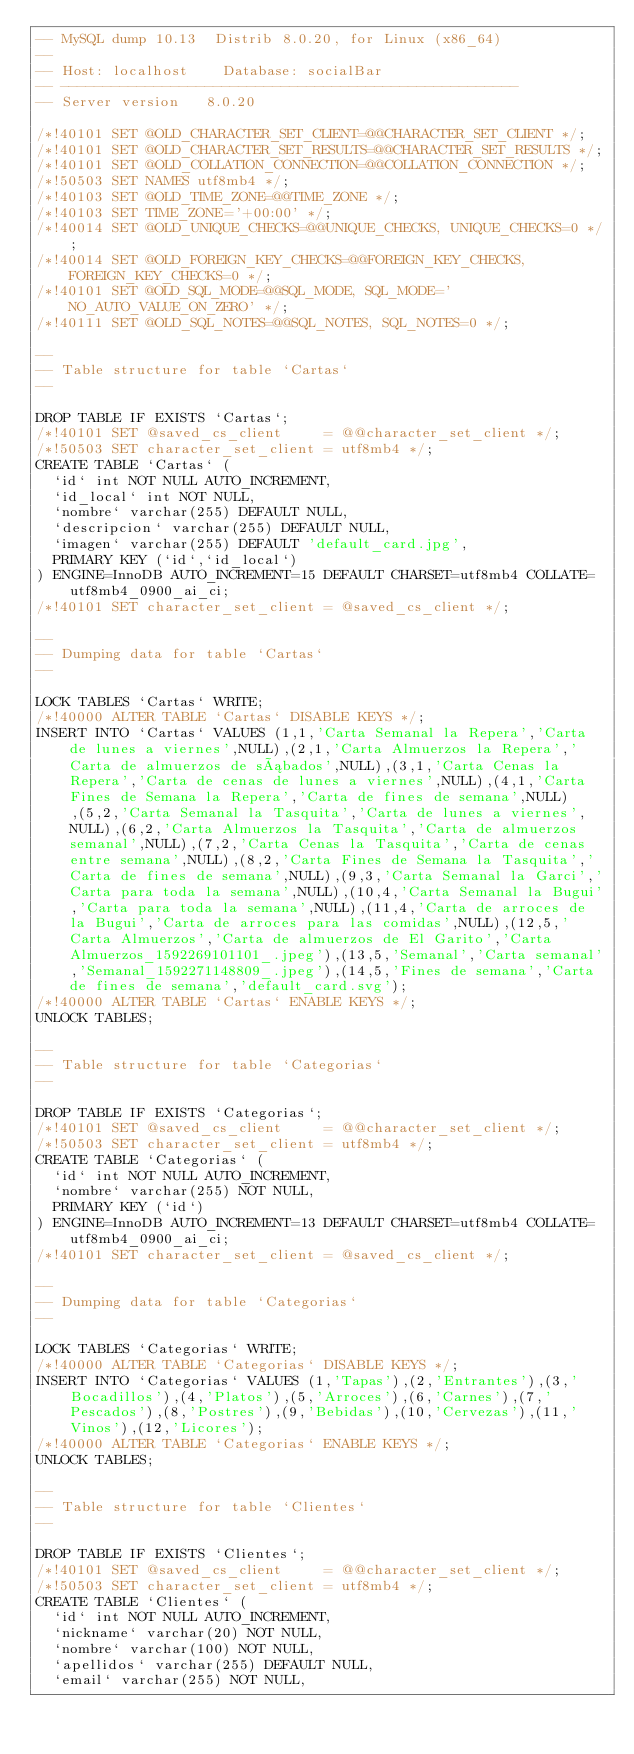Convert code to text. <code><loc_0><loc_0><loc_500><loc_500><_SQL_>-- MySQL dump 10.13  Distrib 8.0.20, for Linux (x86_64)
--
-- Host: localhost    Database: socialBar
-- ------------------------------------------------------
-- Server version	8.0.20

/*!40101 SET @OLD_CHARACTER_SET_CLIENT=@@CHARACTER_SET_CLIENT */;
/*!40101 SET @OLD_CHARACTER_SET_RESULTS=@@CHARACTER_SET_RESULTS */;
/*!40101 SET @OLD_COLLATION_CONNECTION=@@COLLATION_CONNECTION */;
/*!50503 SET NAMES utf8mb4 */;
/*!40103 SET @OLD_TIME_ZONE=@@TIME_ZONE */;
/*!40103 SET TIME_ZONE='+00:00' */;
/*!40014 SET @OLD_UNIQUE_CHECKS=@@UNIQUE_CHECKS, UNIQUE_CHECKS=0 */;
/*!40014 SET @OLD_FOREIGN_KEY_CHECKS=@@FOREIGN_KEY_CHECKS, FOREIGN_KEY_CHECKS=0 */;
/*!40101 SET @OLD_SQL_MODE=@@SQL_MODE, SQL_MODE='NO_AUTO_VALUE_ON_ZERO' */;
/*!40111 SET @OLD_SQL_NOTES=@@SQL_NOTES, SQL_NOTES=0 */;

--
-- Table structure for table `Cartas`
--

DROP TABLE IF EXISTS `Cartas`;
/*!40101 SET @saved_cs_client     = @@character_set_client */;
/*!50503 SET character_set_client = utf8mb4 */;
CREATE TABLE `Cartas` (
  `id` int NOT NULL AUTO_INCREMENT,
  `id_local` int NOT NULL,
  `nombre` varchar(255) DEFAULT NULL,
  `descripcion` varchar(255) DEFAULT NULL,
  `imagen` varchar(255) DEFAULT 'default_card.jpg',
  PRIMARY KEY (`id`,`id_local`)
) ENGINE=InnoDB AUTO_INCREMENT=15 DEFAULT CHARSET=utf8mb4 COLLATE=utf8mb4_0900_ai_ci;
/*!40101 SET character_set_client = @saved_cs_client */;

--
-- Dumping data for table `Cartas`
--

LOCK TABLES `Cartas` WRITE;
/*!40000 ALTER TABLE `Cartas` DISABLE KEYS */;
INSERT INTO `Cartas` VALUES (1,1,'Carta Semanal la Repera','Carta de lunes a viernes',NULL),(2,1,'Carta Almuerzos la Repera','Carta de almuerzos de sábados',NULL),(3,1,'Carta Cenas la Repera','Carta de cenas de lunes a viernes',NULL),(4,1,'Carta Fines de Semana la Repera','Carta de fines de semana',NULL),(5,2,'Carta Semanal la Tasquita','Carta de lunes a viernes',NULL),(6,2,'Carta Almuerzos la Tasquita','Carta de almuerzos semanal',NULL),(7,2,'Carta Cenas la Tasquita','Carta de cenas entre semana',NULL),(8,2,'Carta Fines de Semana la Tasquita','Carta de fines de semana',NULL),(9,3,'Carta Semanal la Garci','Carta para toda la semana',NULL),(10,4,'Carta Semanal la Bugui','Carta para toda la semana',NULL),(11,4,'Carta de arroces de la Bugui','Carta de arroces para las comidas',NULL),(12,5,'Carta Almuerzos','Carta de almuerzos de El Garito','Carta Almuerzos_1592269101101_.jpeg'),(13,5,'Semanal','Carta semanal','Semanal_1592271148809_.jpeg'),(14,5,'Fines de semana','Carta de fines de semana','default_card.svg');
/*!40000 ALTER TABLE `Cartas` ENABLE KEYS */;
UNLOCK TABLES;

--
-- Table structure for table `Categorias`
--

DROP TABLE IF EXISTS `Categorias`;
/*!40101 SET @saved_cs_client     = @@character_set_client */;
/*!50503 SET character_set_client = utf8mb4 */;
CREATE TABLE `Categorias` (
  `id` int NOT NULL AUTO_INCREMENT,
  `nombre` varchar(255) NOT NULL,
  PRIMARY KEY (`id`)
) ENGINE=InnoDB AUTO_INCREMENT=13 DEFAULT CHARSET=utf8mb4 COLLATE=utf8mb4_0900_ai_ci;
/*!40101 SET character_set_client = @saved_cs_client */;

--
-- Dumping data for table `Categorias`
--

LOCK TABLES `Categorias` WRITE;
/*!40000 ALTER TABLE `Categorias` DISABLE KEYS */;
INSERT INTO `Categorias` VALUES (1,'Tapas'),(2,'Entrantes'),(3,'Bocadillos'),(4,'Platos'),(5,'Arroces'),(6,'Carnes'),(7,'Pescados'),(8,'Postres'),(9,'Bebidas'),(10,'Cervezas'),(11,'Vinos'),(12,'Licores');
/*!40000 ALTER TABLE `Categorias` ENABLE KEYS */;
UNLOCK TABLES;

--
-- Table structure for table `Clientes`
--

DROP TABLE IF EXISTS `Clientes`;
/*!40101 SET @saved_cs_client     = @@character_set_client */;
/*!50503 SET character_set_client = utf8mb4 */;
CREATE TABLE `Clientes` (
  `id` int NOT NULL AUTO_INCREMENT,
  `nickname` varchar(20) NOT NULL,
  `nombre` varchar(100) NOT NULL,
  `apellidos` varchar(255) DEFAULT NULL,
  `email` varchar(255) NOT NULL,</code> 